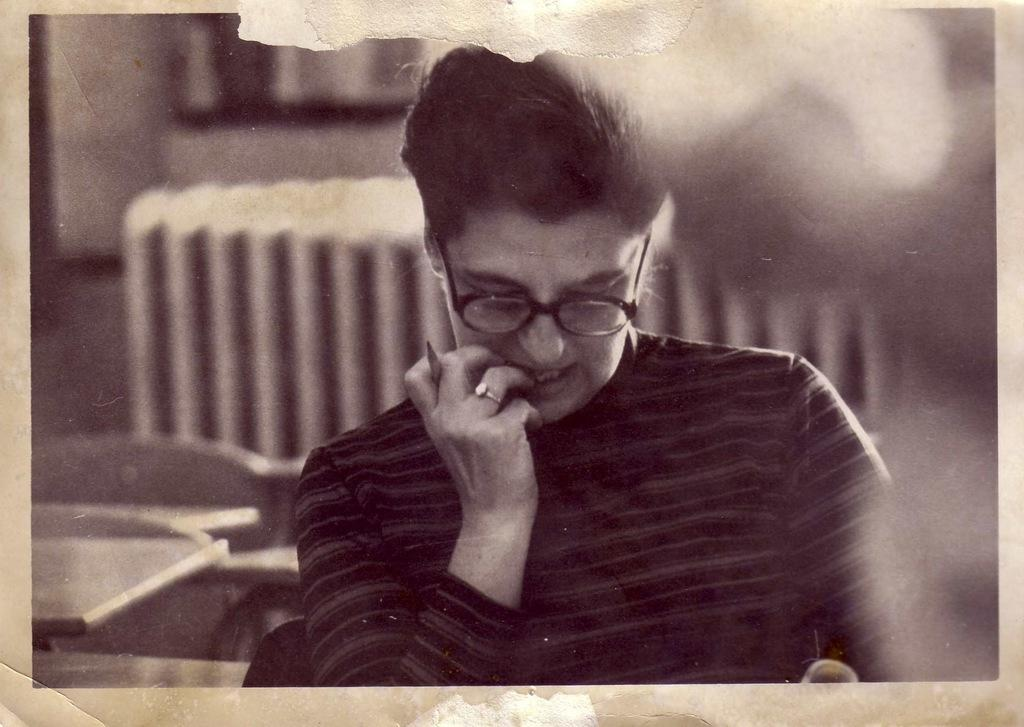What is the main subject of the image? There is a photo in the image. What is the person in the photo doing? The person is sitting in the photo and holding a pen. What can be seen in the background of the photo? There are chairs and tables in the background of the photo. How is the background of the image depicted? The background of the image is blurred. What hobbies does the person in the photo have, as indicated by the note they are holding? There is no note visible in the image, and therefore no indication of the person's hobbies. Can you tell me what is inside the locket the person is wearing in the photo? There is no locket visible on the person in the photo. 